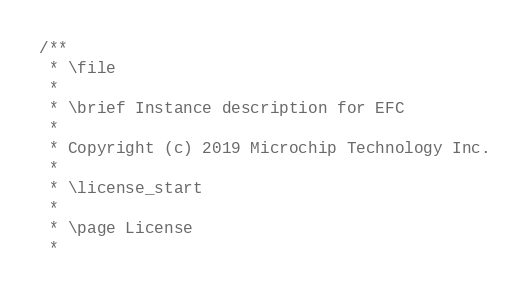<code> <loc_0><loc_0><loc_500><loc_500><_C_>/**
 * \file
 *
 * \brief Instance description for EFC
 *
 * Copyright (c) 2019 Microchip Technology Inc.
 *
 * \license_start
 *
 * \page License
 *</code> 